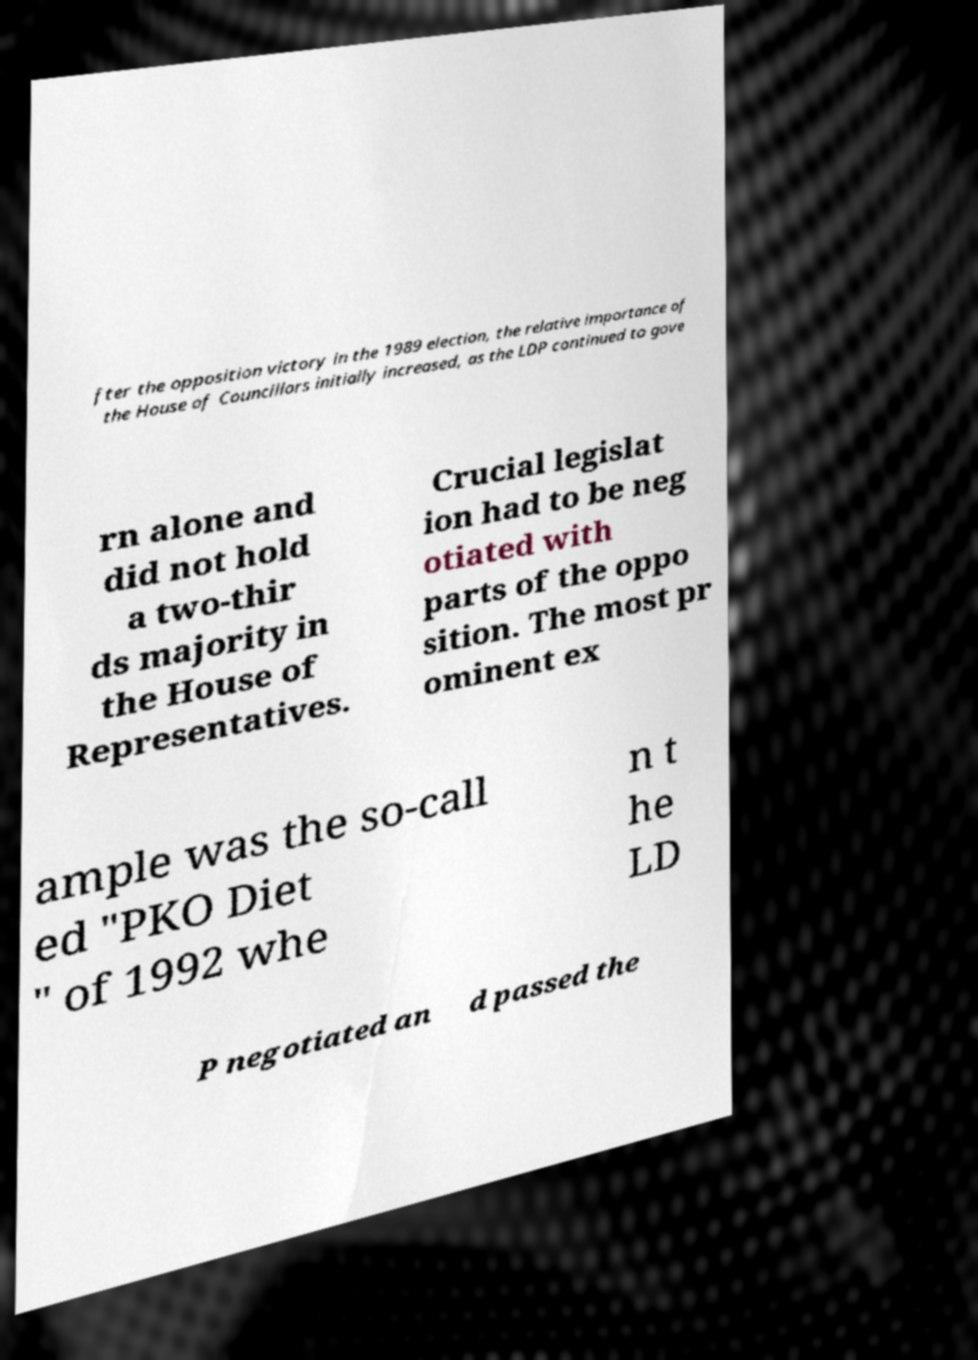Could you extract and type out the text from this image? fter the opposition victory in the 1989 election, the relative importance of the House of Councillors initially increased, as the LDP continued to gove rn alone and did not hold a two-thir ds majority in the House of Representatives. Crucial legislat ion had to be neg otiated with parts of the oppo sition. The most pr ominent ex ample was the so-call ed "PKO Diet " of 1992 whe n t he LD P negotiated an d passed the 